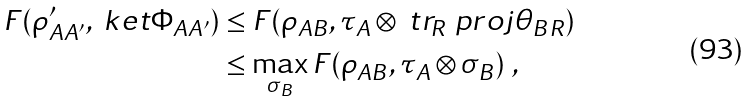<formula> <loc_0><loc_0><loc_500><loc_500>F ( \rho ^ { \prime } _ { A A ^ { \prime } } , \ k e t { \Phi _ { A A ^ { \prime } } } ) & \leq F ( \rho _ { A B } , \tau _ { A } \otimes \ t r _ { R } \ p r o j { \theta _ { B R } } ) \\ & \leq \max _ { \sigma _ { B } } F ( \rho _ { A B } , \tau _ { A } \otimes \sigma _ { B } ) \ ,</formula> 